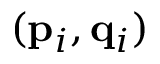Convert formula to latex. <formula><loc_0><loc_0><loc_500><loc_500>( { p } _ { i } , { q } _ { i } )</formula> 